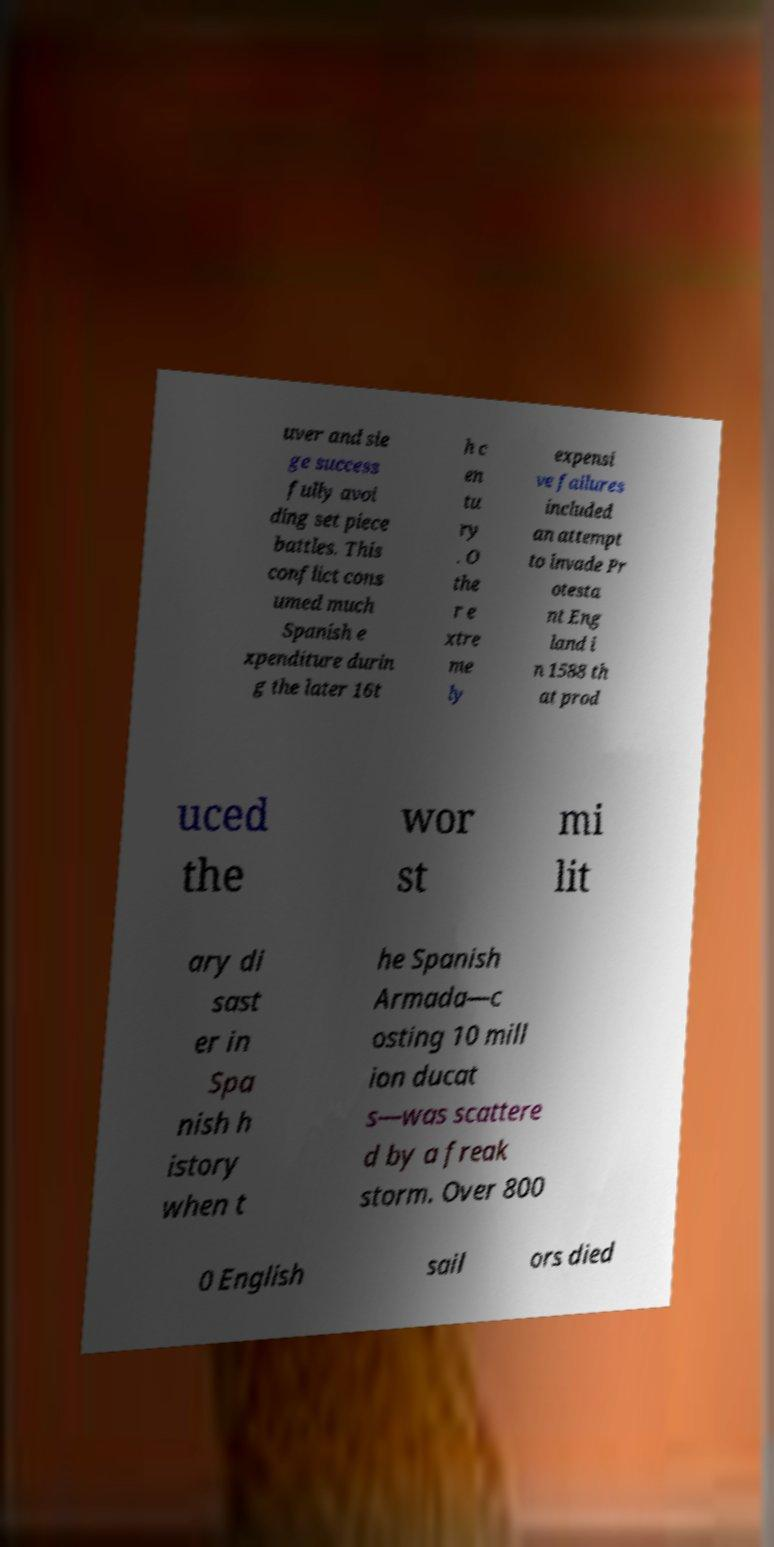Please read and relay the text visible in this image. What does it say? uver and sie ge success fully avoi ding set piece battles. This conflict cons umed much Spanish e xpenditure durin g the later 16t h c en tu ry . O the r e xtre me ly expensi ve failures included an attempt to invade Pr otesta nt Eng land i n 1588 th at prod uced the wor st mi lit ary di sast er in Spa nish h istory when t he Spanish Armada—c osting 10 mill ion ducat s—was scattere d by a freak storm. Over 800 0 English sail ors died 